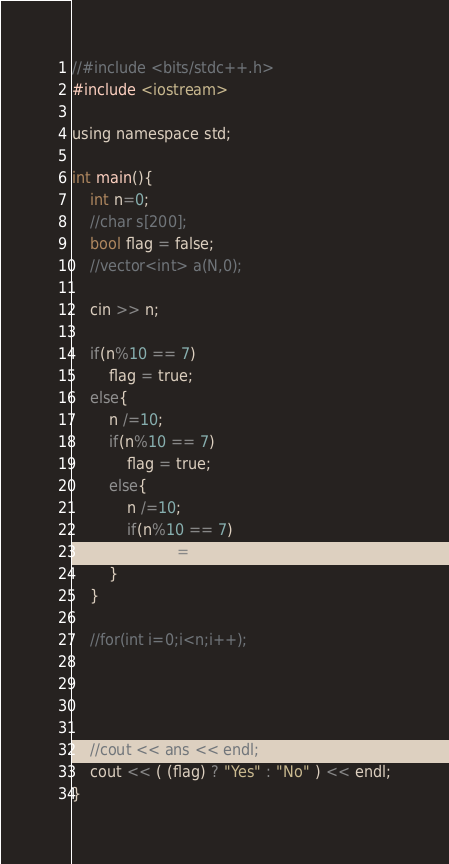Convert code to text. <code><loc_0><loc_0><loc_500><loc_500><_C_>//#include <bits/stdc++.h>
#include <iostream>

using namespace std;

int main(){
    int n=0;
    //char s[200];
    bool flag = false;
    //vector<int> a(N,0);

    cin >> n;

    if(n%10 == 7)
        flag = true;
    else{
        n /=10;
        if(n%10 == 7)
            flag = true;
        else{
            n /=10;
            if(n%10 == 7)
                flag = true;
        }
    }
    
    //for(int i=0;i<n;i++);


    

    //cout << ans << endl;
    cout << ( (flag) ? "Yes" : "No" ) << endl;
}
</code> 